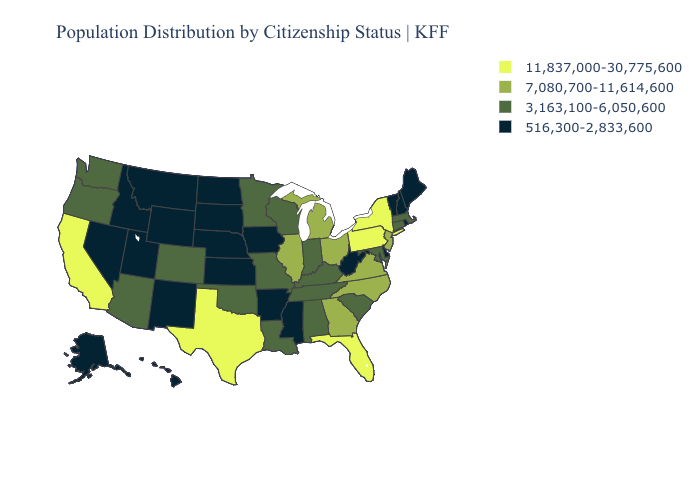What is the value of Iowa?
Give a very brief answer. 516,300-2,833,600. Name the states that have a value in the range 7,080,700-11,614,600?
Concise answer only. Georgia, Illinois, Michigan, New Jersey, North Carolina, Ohio, Virginia. Name the states that have a value in the range 3,163,100-6,050,600?
Short answer required. Alabama, Arizona, Colorado, Connecticut, Indiana, Kentucky, Louisiana, Maryland, Massachusetts, Minnesota, Missouri, Oklahoma, Oregon, South Carolina, Tennessee, Washington, Wisconsin. What is the value of Connecticut?
Give a very brief answer. 3,163,100-6,050,600. Name the states that have a value in the range 11,837,000-30,775,600?
Write a very short answer. California, Florida, New York, Pennsylvania, Texas. Among the states that border Tennessee , does Kentucky have the lowest value?
Be succinct. No. Does Montana have the highest value in the USA?
Concise answer only. No. What is the lowest value in the USA?
Give a very brief answer. 516,300-2,833,600. What is the highest value in the West ?
Write a very short answer. 11,837,000-30,775,600. Name the states that have a value in the range 516,300-2,833,600?
Keep it brief. Alaska, Arkansas, Delaware, Hawaii, Idaho, Iowa, Kansas, Maine, Mississippi, Montana, Nebraska, Nevada, New Hampshire, New Mexico, North Dakota, Rhode Island, South Dakota, Utah, Vermont, West Virginia, Wyoming. Which states have the highest value in the USA?
Keep it brief. California, Florida, New York, Pennsylvania, Texas. Does Hawaii have the lowest value in the USA?
Concise answer only. Yes. What is the lowest value in states that border Michigan?
Be succinct. 3,163,100-6,050,600. Among the states that border Washington , does Oregon have the highest value?
Keep it brief. Yes. Name the states that have a value in the range 7,080,700-11,614,600?
Answer briefly. Georgia, Illinois, Michigan, New Jersey, North Carolina, Ohio, Virginia. 